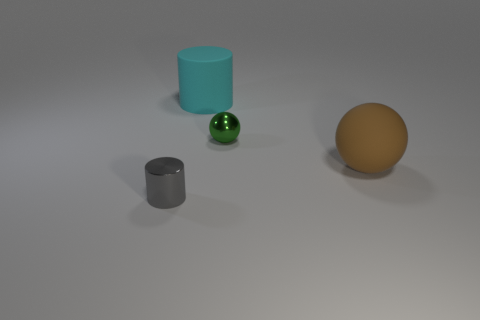Are there any cylinders that are right of the metal thing on the left side of the ball on the left side of the large sphere?
Ensure brevity in your answer.  Yes. Does the big object in front of the big cyan rubber cylinder have the same shape as the green thing?
Ensure brevity in your answer.  Yes. Is the number of small green metallic things that are behind the tiny metal sphere less than the number of tiny gray shiny things right of the large brown sphere?
Keep it short and to the point. No. What is the material of the green ball?
Offer a very short reply. Metal. There is a rubber cylinder; what number of large rubber spheres are to the left of it?
Your answer should be very brief. 0. Are there fewer brown balls on the left side of the big cyan thing than large yellow shiny blocks?
Offer a very short reply. No. The matte ball is what color?
Your answer should be compact. Brown. Is the color of the tiny ball behind the brown matte ball the same as the tiny cylinder?
Offer a terse response. No. What color is the tiny metal thing that is the same shape as the large brown rubber object?
Provide a short and direct response. Green. How many tiny objects are either metal spheres or brown balls?
Your answer should be very brief. 1. 